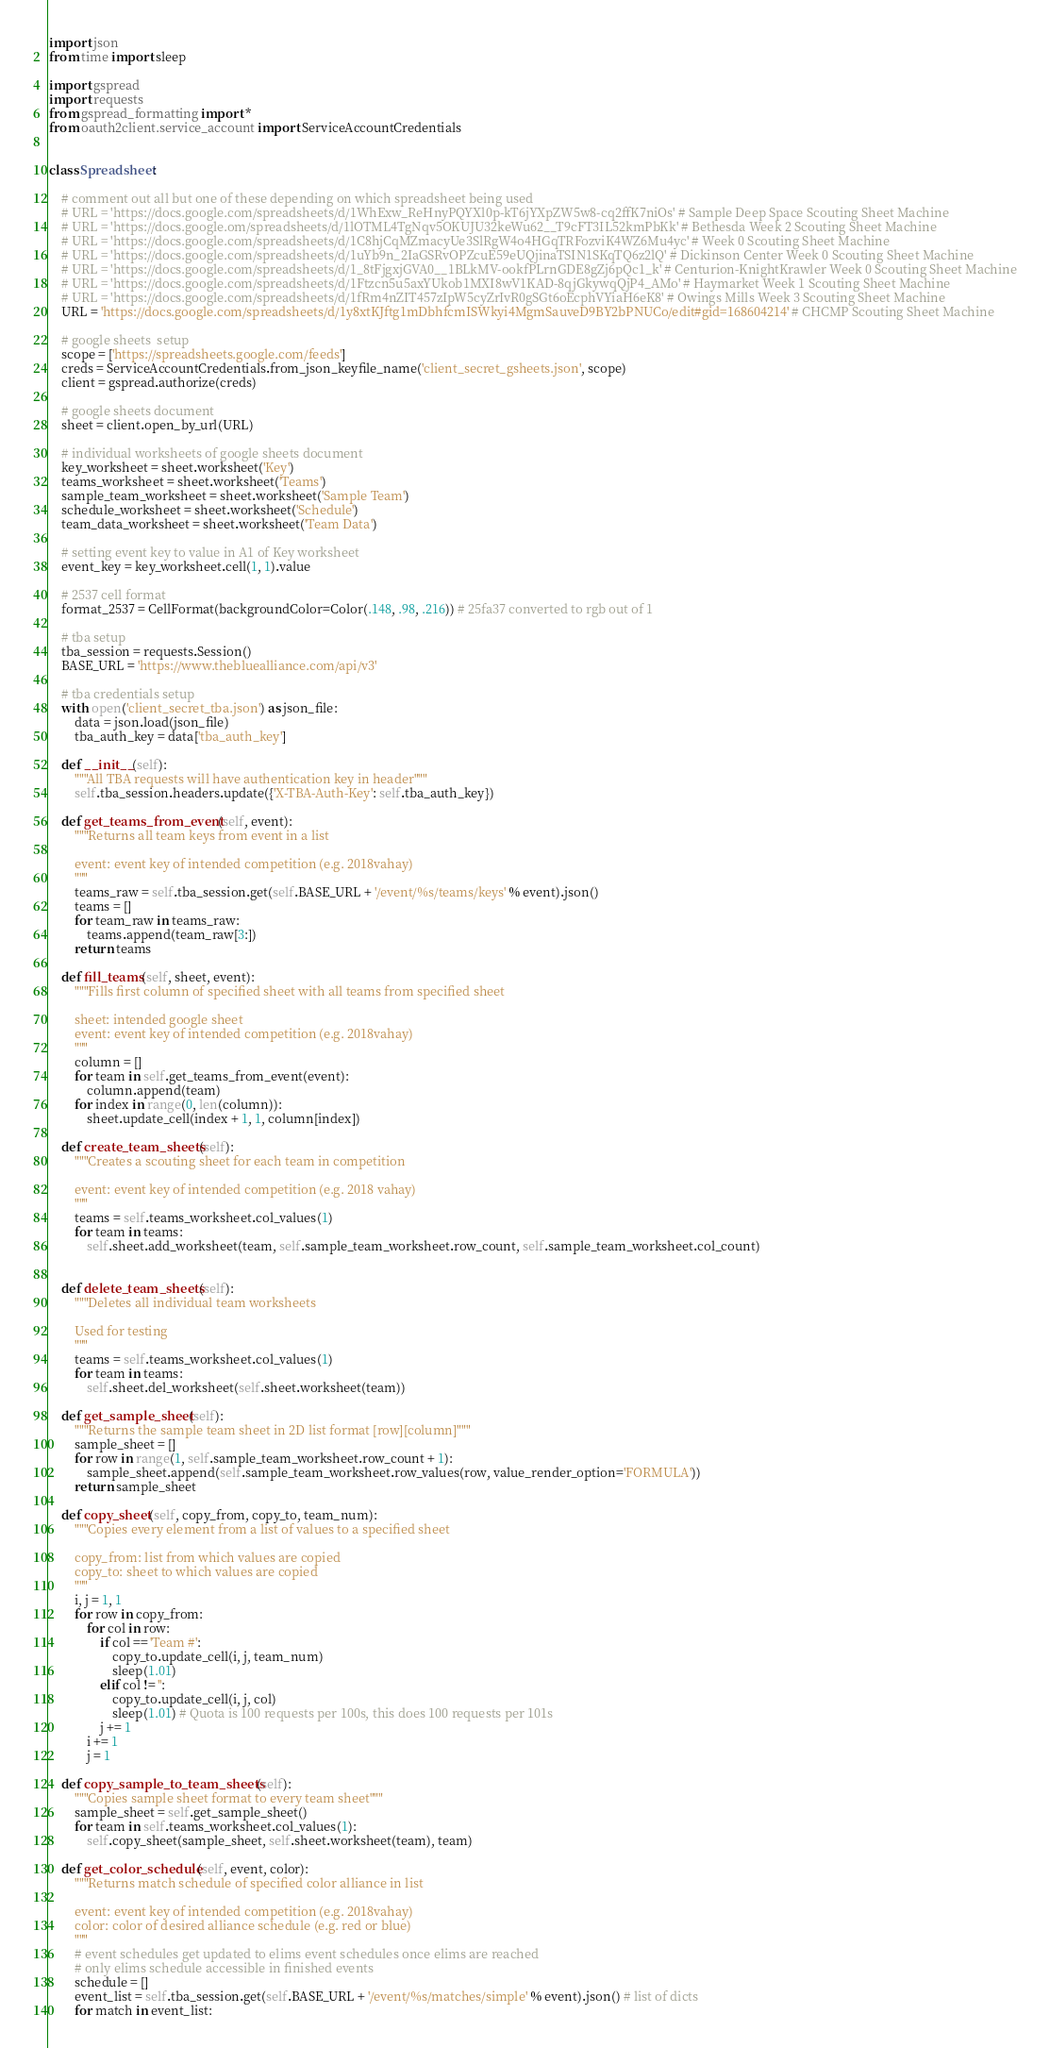Convert code to text. <code><loc_0><loc_0><loc_500><loc_500><_Python_>import json
from time import sleep

import gspread
import requests
from gspread_formatting import *
from oauth2client.service_account import ServiceAccountCredentials


class Spreadsheet:

    # comment out all but one of these depending on which spreadsheet being used
    # URL = 'https://docs.google.com/spreadsheets/d/1WhExw_ReHnyPQYXl0p-kT6jYXpZW5w8-cq2ffK7niOs' # Sample Deep Space Scouting Sheet Machine
    # URL = 'https://docs.google.om/spreadsheets/d/1lOTML4TgNqv5OKUJU32keWu62__T9cFT3IL52kmPbKk' # Bethesda Week 2 Scouting Sheet Machine
    # URL = 'https://docs.google.com/spreadsheets/d/1C8hjCqMZmacyUe3SlRgW4o4HGqTRFozviK4WZ6Mu4yc' # Week 0 Scouting Sheet Machine
    # URL = 'https://docs.google.com/spreadsheets/d/1uYb9n_2IaGSRvOPZcuE59eUQjinaTSIN1SKqTQ6z2lQ' # Dickinson Center Week 0 Scouting Sheet Machine
    # URL = 'https://docs.google.com/spreadsheets/d/1_8tFjgxjGVA0__1BLkMV-ookfPLrnGDE8gZj6pQc1_k' # Centurion-KnightKrawler Week 0 Scouting Sheet Machine
    # URL = 'https://docs.google.com/spreadsheets/d/1Ftzcn5u5axYUkob1MXI8wV1KAD-8qjGkywqQjP4_AMo' # Haymarket Week 1 Scouting Sheet Machine
    # URL = 'https://docs.google.com/spreadsheets/d/1fRm4nZIT457zIpW5cyZrIvR0gSGt6oEcphVYiaH6eK8' # Owings Mills Week 3 Scouting Sheet Machine
    URL = 'https://docs.google.com/spreadsheets/d/1y8xtKJftg1mDbhfcmISWkyi4MgmSauveD9BY2bPNUCo/edit#gid=168604214' # CHCMP Scouting Sheet Machine

    # google sheets  setup
    scope = ['https://spreadsheets.google.com/feeds']
    creds = ServiceAccountCredentials.from_json_keyfile_name('client_secret_gsheets.json', scope)
    client = gspread.authorize(creds)

    # google sheets document
    sheet = client.open_by_url(URL)
    
    # individual worksheets of google sheets document
    key_worksheet = sheet.worksheet('Key')
    teams_worksheet = sheet.worksheet('Teams')
    sample_team_worksheet = sheet.worksheet('Sample Team')
    schedule_worksheet = sheet.worksheet('Schedule')
    team_data_worksheet = sheet.worksheet('Team Data')

    # setting event key to value in A1 of Key worksheet
    event_key = key_worksheet.cell(1, 1).value

    # 2537 cell format
    format_2537 = CellFormat(backgroundColor=Color(.148, .98, .216)) # 25fa37 converted to rgb out of 1

    # tba setup
    tba_session = requests.Session()
    BASE_URL = 'https://www.thebluealliance.com/api/v3'

    # tba credentials setup
    with open('client_secret_tba.json') as json_file:
        data = json.load(json_file)
        tba_auth_key = data['tba_auth_key']

    def __init__(self):
        """All TBA requests will have authentication key in header"""
        self.tba_session.headers.update({'X-TBA-Auth-Key': self.tba_auth_key})

    def get_teams_from_event(self, event):
        """Returns all team keys from event in a list
        
        event: event key of intended competition (e.g. 2018vahay)
        """
        teams_raw = self.tba_session.get(self.BASE_URL + '/event/%s/teams/keys' % event).json()
        teams = []
        for team_raw in teams_raw:
            teams.append(team_raw[3:])
        return teams

    def fill_teams(self, sheet, event):
        """Fills first column of specified sheet with all teams from specified sheet
        
        sheet: intended google sheet
        event: event key of intended competition (e.g. 2018vahay)
        """
        column = []
        for team in self.get_teams_from_event(event):
            column.append(team)
        for index in range(0, len(column)):
            sheet.update_cell(index + 1, 1, column[index])

    def create_team_sheets(self):
        """Creates a scouting sheet for each team in competition

        event: event key of intended competition (e.g. 2018 vahay)
        """
        teams = self.teams_worksheet.col_values(1)
        for team in teams:
            self.sheet.add_worksheet(team, self.sample_team_worksheet.row_count, self.sample_team_worksheet.col_count)


    def delete_team_sheets(self):
        """Deletes all individual team worksheets

        Used for testing
        """
        teams = self.teams_worksheet.col_values(1)
        for team in teams:
            self.sheet.del_worksheet(self.sheet.worksheet(team))

    def get_sample_sheet(self):
        """Returns the sample team sheet in 2D list format [row][column]"""
        sample_sheet = []
        for row in range(1, self.sample_team_worksheet.row_count + 1):
            sample_sheet.append(self.sample_team_worksheet.row_values(row, value_render_option='FORMULA'))
        return sample_sheet

    def copy_sheet(self, copy_from, copy_to, team_num):
        """Copies every element from a list of values to a specified sheet

        copy_from: list from which values are copied
        copy_to: sheet to which values are copied
        """
        i, j = 1, 1
        for row in copy_from:
            for col in row:
                if col == 'Team #':
                    copy_to.update_cell(i, j, team_num)
                    sleep(1.01)
                elif col != '':
                    copy_to.update_cell(i, j, col)
                    sleep(1.01) # Quota is 100 requests per 100s, this does 100 requests per 101s
                j += 1
            i += 1
            j = 1

    def copy_sample_to_team_sheets(self):
        """Copies sample sheet format to every team sheet"""
        sample_sheet = self.get_sample_sheet()
        for team in self.teams_worksheet.col_values(1):
            self.copy_sheet(sample_sheet, self.sheet.worksheet(team), team)

    def get_color_schedule(self, event, color):
        """Returns match schedule of specified color alliance in list
        
        event: event key of intended competition (e.g. 2018vahay)
        color: color of desired alliance schedule (e.g. red or blue)
        """
        # event schedules get updated to elims event schedules once elims are reached
        # only elims schedule accessible in finished events
        schedule = []
        event_list = self.tba_session.get(self.BASE_URL + '/event/%s/matches/simple' % event).json() # list of dicts
        for match in event_list:</code> 